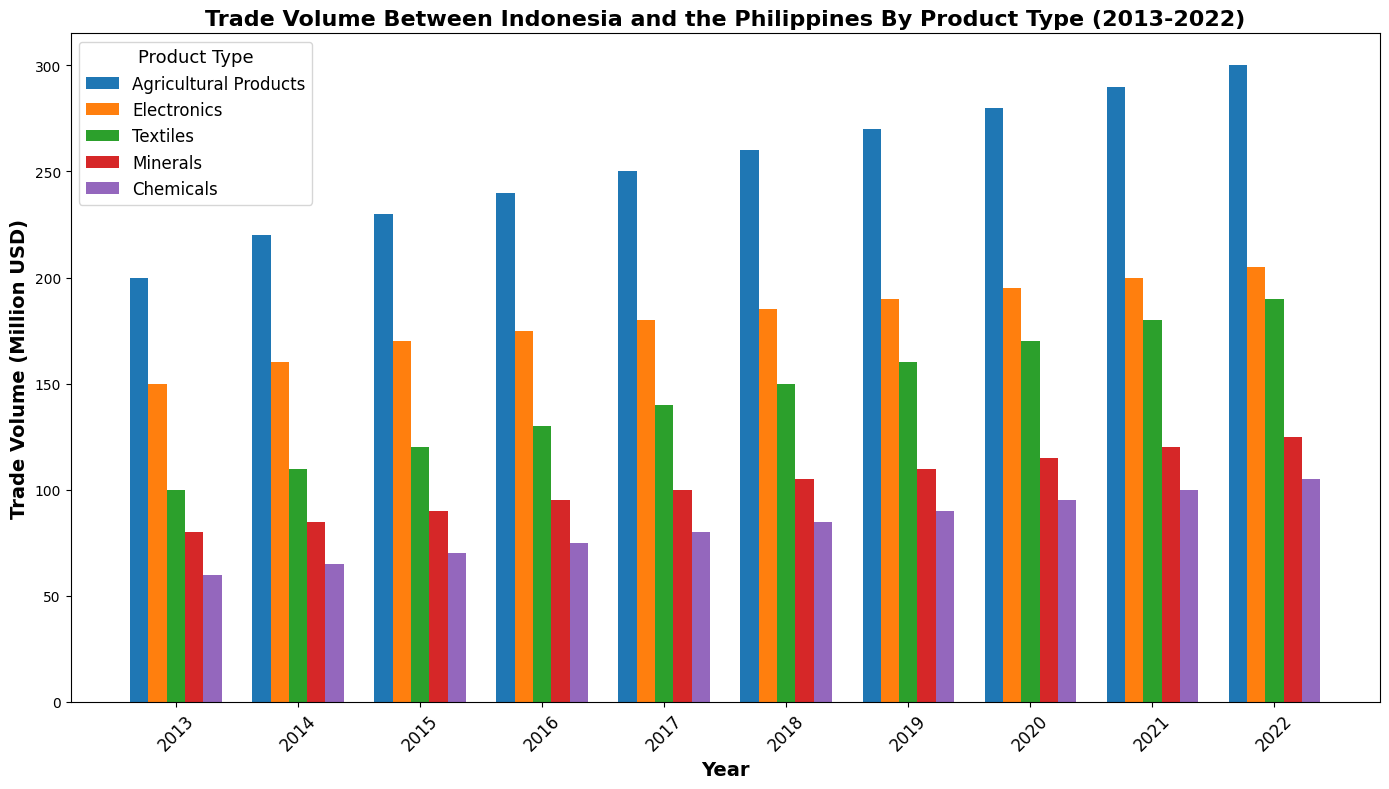How did the trade volume of Agricultural Products change from 2013 to 2022? To determine this, observe the heights of the bars corresponding to Agricultural Products for the years 2013 and 2022. In 2013, the volume is 200 million USD, and in 2022, it is 300 million USD. The change is 300 - 200 = 100 million USD.
Answer: Increased by 100 million USD Which product type had the highest trade volume in 2022? Examine the height of the bars for each product type in 2022. The highest bar corresponds to Agricultural Products, with a trade volume of 300 million USD.
Answer: Agricultural Products How much did the trade volume for Electronics increase from 2013 to 2022? Compare the heights of the bars for Electronics in 2013 and 2022. In 2013, the volume is 150 million USD, and in 2022, it is 205 million USD. The increase is 205 - 150 = 55 million USD.
Answer: Increased by 55 million USD Which product had the smallest increase in trade volume over the decade? Calculate the increase for each product type from 2013 to 2022: Agricultural Products (300-200=100), Electronics (205-150=55), Textiles (190-100=90), Minerals (125-80=45), Chemicals (105-60=45). The smallest increases are for Minerals and Chemicals, both at 45 million USD.
Answer: Minerals and Chemicals Between Agricultural Products and Textiles, which saw a greater increase in trade volume from 2013 to 2022? Calculate the increase for both product types: Agricultural Products (300-200=100), Textiles (190-100=90). Agricultural Products had a greater increase.
Answer: Agricultural Products In what year did Electronics surpass 180 million USD in trade volume? Scan the bars for Electronics year by year. The bar for 2017 reaches 180 million USD, and the bar for 2018 surpasses it, reaching 185 million USD. Therefore, Electronics surpassed 180 million USD in 2018.
Answer: 2018 In 2019, which product had the closest trade volume to 90 million USD? Look at the heights of the bars for each product type in 2019. Chemicals have a trade volume of 90 million USD, which is the closest to 90 million USD.
Answer: Chemicals What was the average annual trade volume of Textiles from 2013 to 2022? Sum up the trade volumes for Textiles over the years (100 + 110 + 120 + 130 + 140 + 150 + 160 + 170 + 180 + 190 = 1450 million USD). Divide by the number of years (10). The average is 1450 / 10 = 145 million USD.
Answer: 145 million USD Compare the trend of trade volumes for Minerals and Chemicals over the decade. Which shows a more consistent increase? Observe the bars for Minerals and Chemicals year by year. Both show an increase every year, but the increments for Minerals (80, 85, 90, 95, 100, 105, 110, 115, 120, 125) are more even, whereas Chemicals show smaller increases in early years and larger in later years. Minerals show a more consistent increase.
Answer: Minerals What year had the lowest total trade volume across all product types? Calculate the total trade volume for each year by summing the volumes for all product types. For instance, for 2013: 200 + 150 + 100 + 80 + 60 = 590 million USD. Repeating this for all years, the values are: 590, 640, 700, 715, 750, 785, 820, 850, 880, 925 million USD. The lowest total is 590 million USD in 2013.
Answer: 2013 